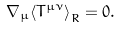Convert formula to latex. <formula><loc_0><loc_0><loc_500><loc_500>\nabla _ { \mu } { \langle T ^ { \mu \nu } \rangle } _ { R } = 0 .</formula> 